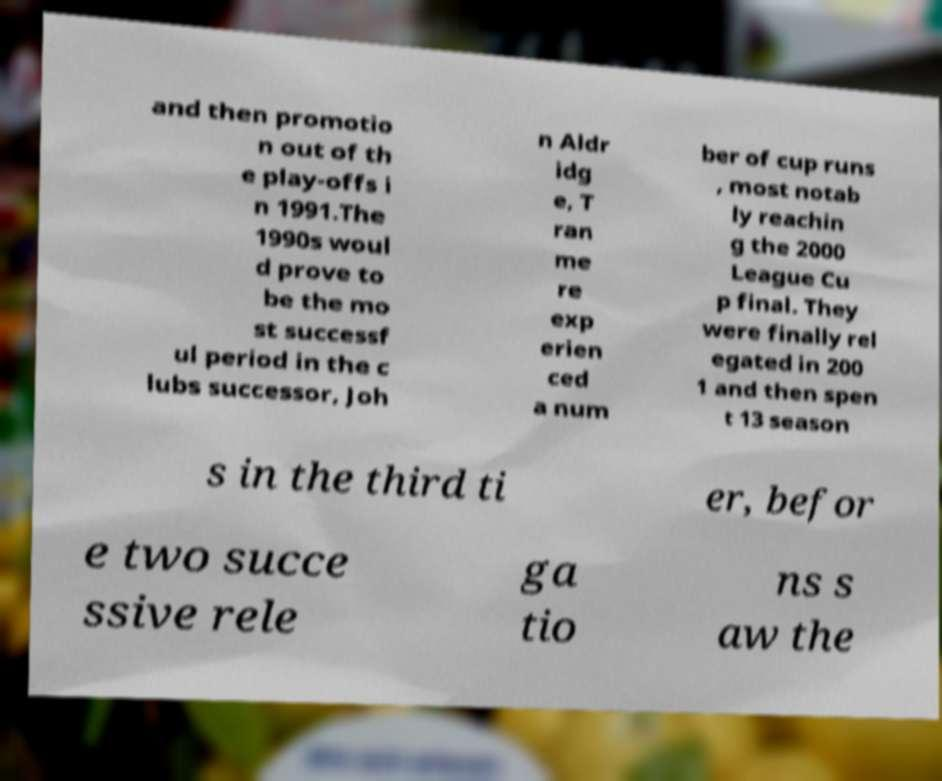Please identify and transcribe the text found in this image. and then promotio n out of th e play-offs i n 1991.The 1990s woul d prove to be the mo st successf ul period in the c lubs successor, Joh n Aldr idg e, T ran me re exp erien ced a num ber of cup runs , most notab ly reachin g the 2000 League Cu p final. They were finally rel egated in 200 1 and then spen t 13 season s in the third ti er, befor e two succe ssive rele ga tio ns s aw the 